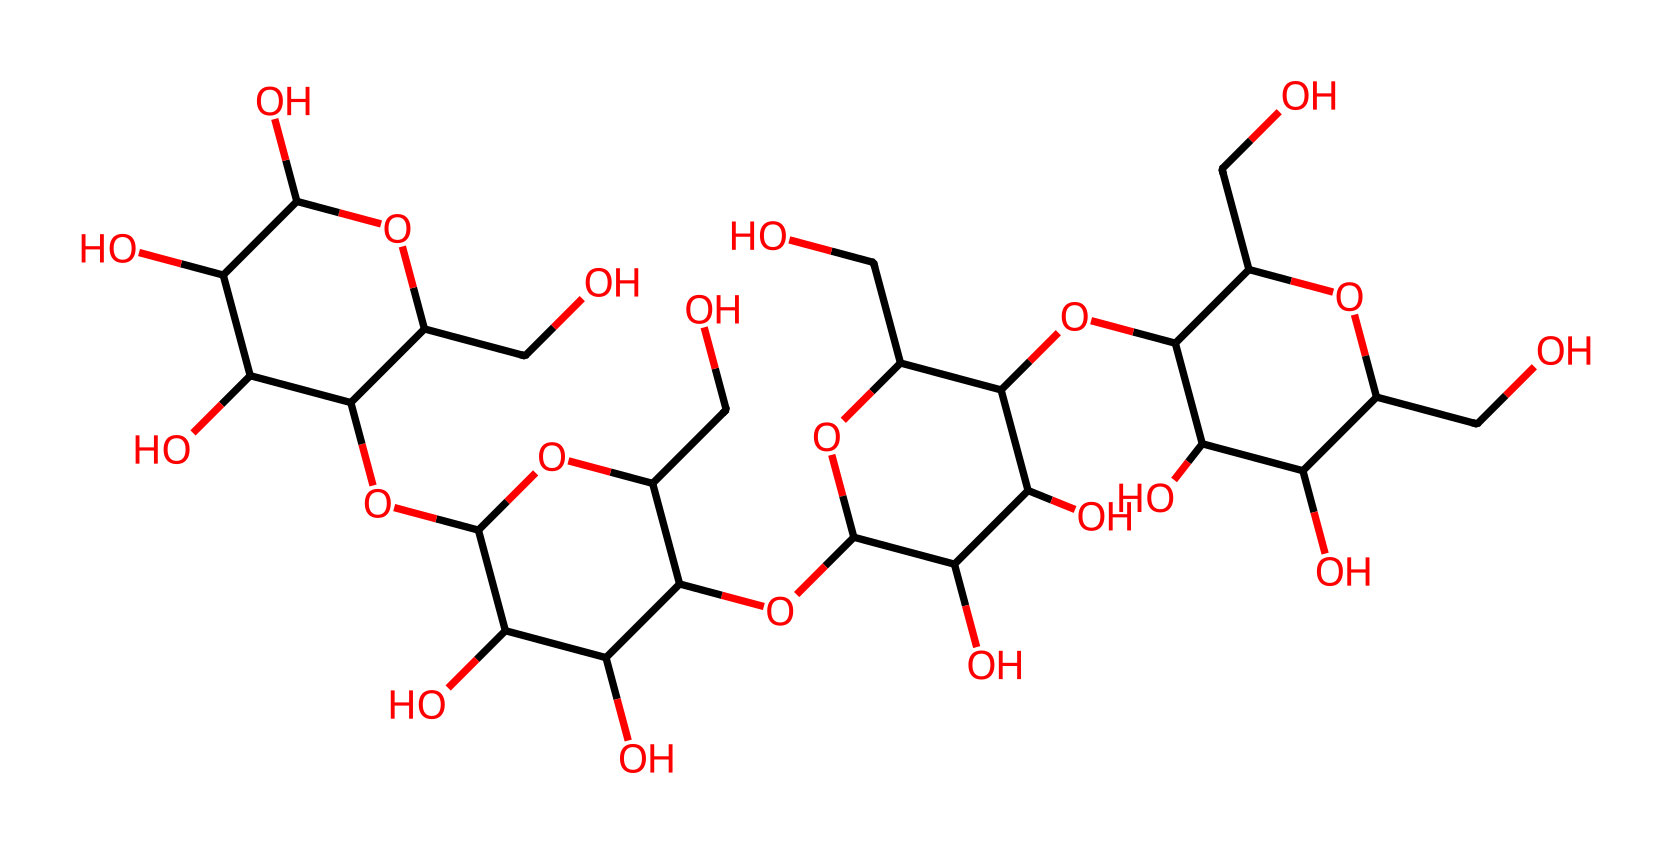What is the primary component of oobleck? The chemical structure depicts various hydroxyl groups and carbons typically associated with polysaccharides, specifically, it structure resembles that of cornstarch when considering its building blocks.
Answer: cornstarch How many rings are present in this chemical structure? By analyzing the SMILES representation, specifically looking for 'C1' and 'C2', we see a total of three ring structures based on the cyclic notations.
Answer: three What class of non-Newtonian fluid is represented by this chemical? Oobleck is identified as a shear-thickening non-Newtonian fluid, which means it thickens upon the application of stress, a behavior inferred from its polysaccharide-like composition.
Answer: shear-thickening How many oxygen atoms are in this chemical? Counting from the SMILES representation, we can identify a total of fifteen oxygen atoms present throughout the structure by identifying individual 'O' symbols.
Answer: fifteen What property of this chemical helps it behave as a non-Newtonian fluid? The interactions between the long-chain molecules in the structure cause it to become more viscous under stress, which is crucial for its non-Newtonian behavior.
Answer: viscosity What type of bonds predominantly exist in this chemical structure? The presence of multiple -OH (hydroxyl) groups suggests that hydrogen bonds are predominant in this chemical, which is significant for both solubility and its non-Newtonian behavior.
Answer: hydrogen bonds 